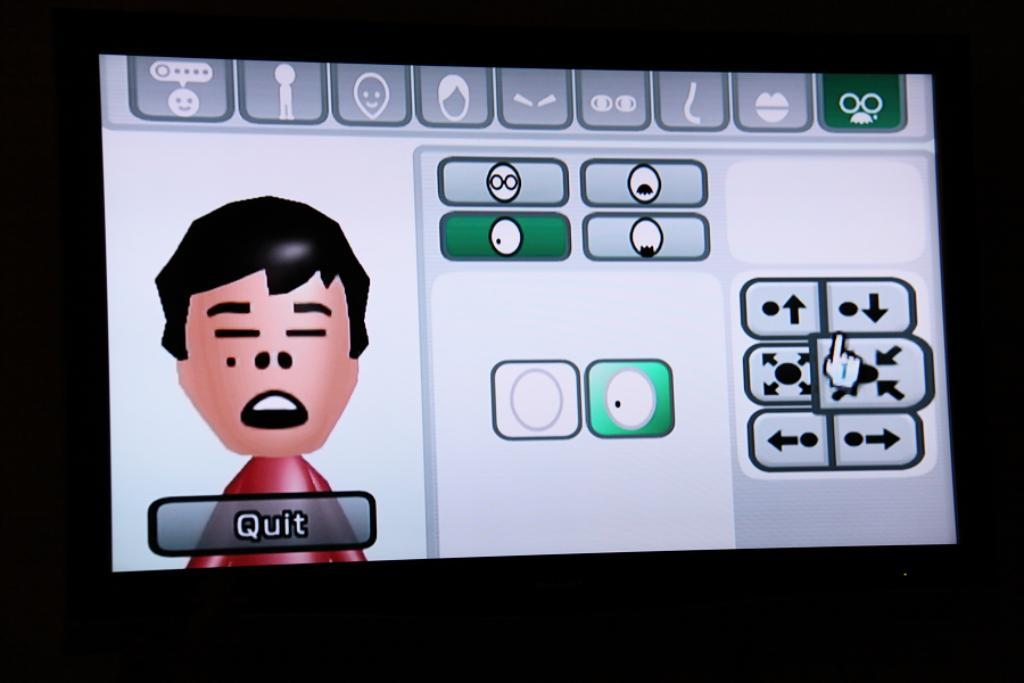What type of image is being described? The image is animated. What can be found within the animated image? There are symbols and a cartoon image in the image. Is there any text present in the image? Yes, there is text written in the image. What type of vacation is the dad planning in the image? There is no mention of a vacation or a dad in the image, so it cannot be determined from the image. 